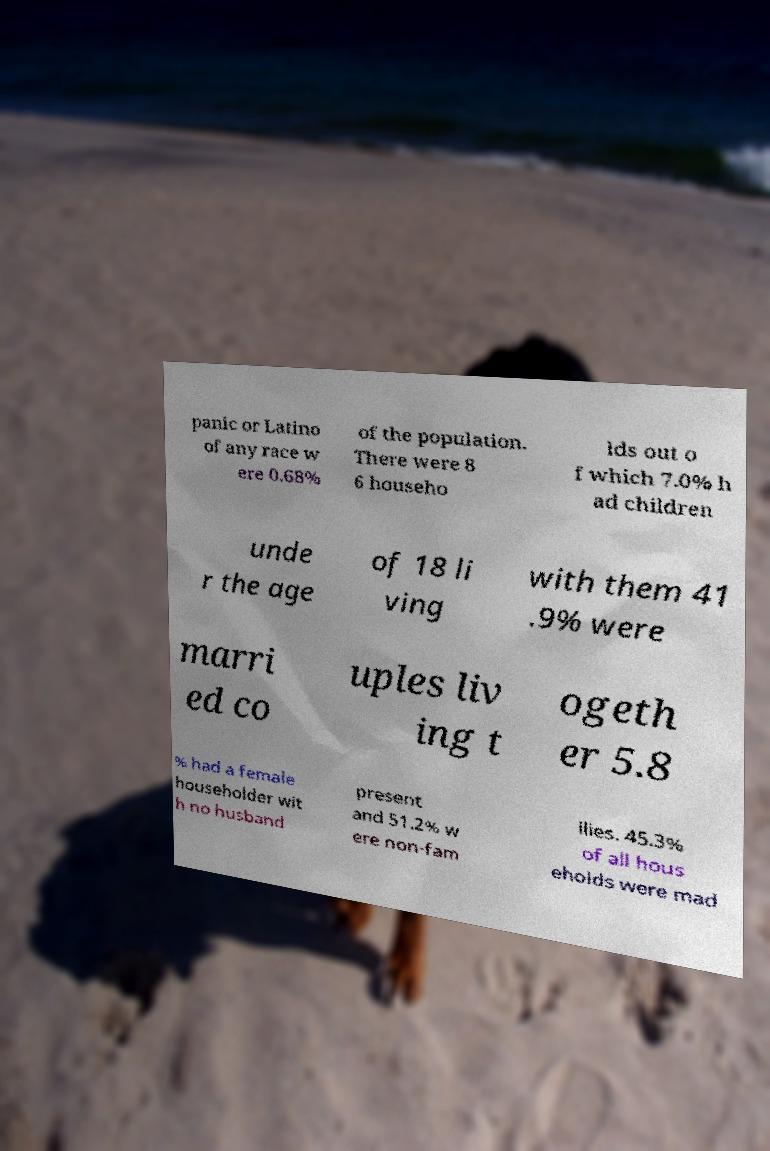What messages or text are displayed in this image? I need them in a readable, typed format. panic or Latino of any race w ere 0.68% of the population. There were 8 6 househo lds out o f which 7.0% h ad children unde r the age of 18 li ving with them 41 .9% were marri ed co uples liv ing t ogeth er 5.8 % had a female householder wit h no husband present and 51.2% w ere non-fam ilies. 45.3% of all hous eholds were mad 